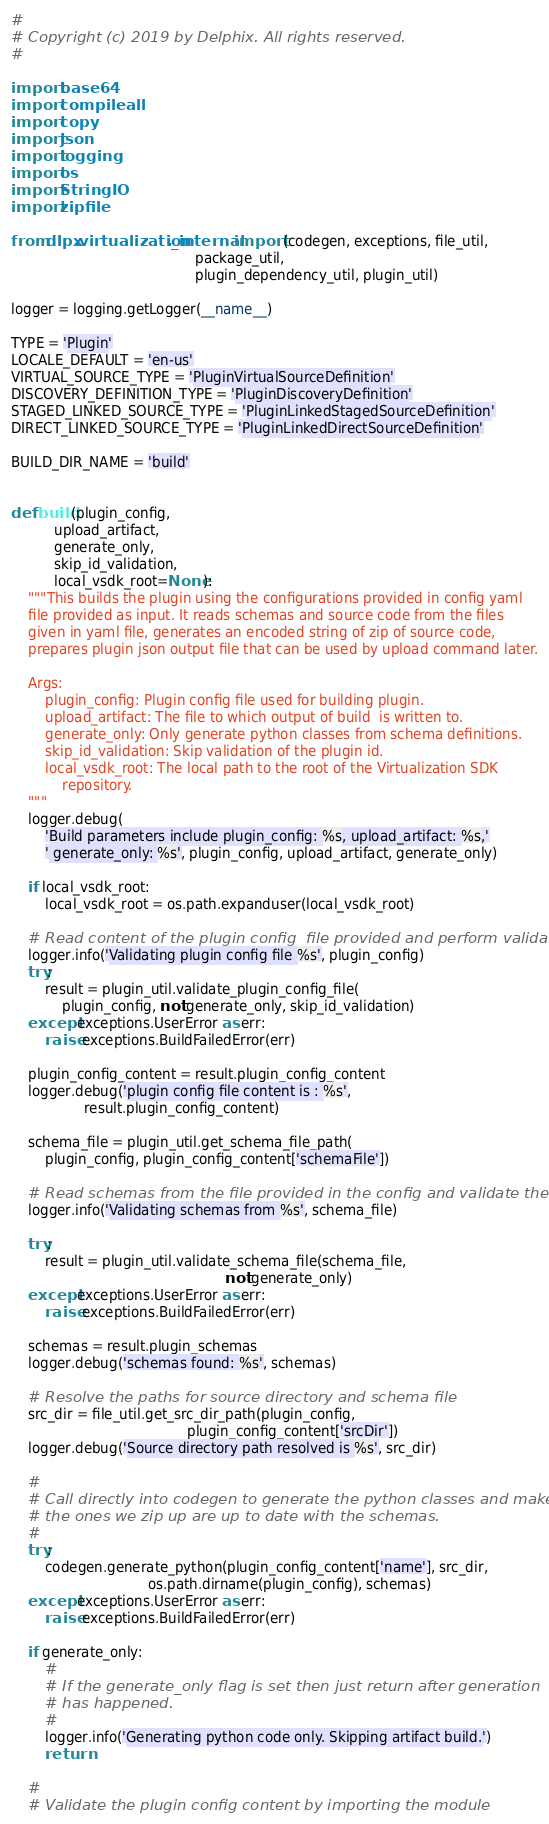<code> <loc_0><loc_0><loc_500><loc_500><_Python_>#
# Copyright (c) 2019 by Delphix. All rights reserved.
#

import base64
import compileall
import copy
import json
import logging
import os
import StringIO
import zipfile

from dlpx.virtualization._internal import (codegen, exceptions, file_util,
                                           package_util,
                                           plugin_dependency_util, plugin_util)

logger = logging.getLogger(__name__)

TYPE = 'Plugin'
LOCALE_DEFAULT = 'en-us'
VIRTUAL_SOURCE_TYPE = 'PluginVirtualSourceDefinition'
DISCOVERY_DEFINITION_TYPE = 'PluginDiscoveryDefinition'
STAGED_LINKED_SOURCE_TYPE = 'PluginLinkedStagedSourceDefinition'
DIRECT_LINKED_SOURCE_TYPE = 'PluginLinkedDirectSourceDefinition'

BUILD_DIR_NAME = 'build'


def build(plugin_config,
          upload_artifact,
          generate_only,
          skip_id_validation,
          local_vsdk_root=None):
    """This builds the plugin using the configurations provided in config yaml
    file provided as input. It reads schemas and source code from the files
    given in yaml file, generates an encoded string of zip of source code,
    prepares plugin json output file that can be used by upload command later.

    Args:
        plugin_config: Plugin config file used for building plugin.
        upload_artifact: The file to which output of build  is written to.
        generate_only: Only generate python classes from schema definitions.
        skip_id_validation: Skip validation of the plugin id.
        local_vsdk_root: The local path to the root of the Virtualization SDK
            repository.
    """
    logger.debug(
        'Build parameters include plugin_config: %s, upload_artifact: %s,'
        ' generate_only: %s', plugin_config, upload_artifact, generate_only)

    if local_vsdk_root:
        local_vsdk_root = os.path.expanduser(local_vsdk_root)

    # Read content of the plugin config  file provided and perform validations
    logger.info('Validating plugin config file %s', plugin_config)
    try:
        result = plugin_util.validate_plugin_config_file(
            plugin_config, not generate_only, skip_id_validation)
    except exceptions.UserError as err:
        raise exceptions.BuildFailedError(err)

    plugin_config_content = result.plugin_config_content
    logger.debug('plugin config file content is : %s',
                 result.plugin_config_content)

    schema_file = plugin_util.get_schema_file_path(
        plugin_config, plugin_config_content['schemaFile'])

    # Read schemas from the file provided in the config and validate them
    logger.info('Validating schemas from %s', schema_file)

    try:
        result = plugin_util.validate_schema_file(schema_file,
                                                  not generate_only)
    except exceptions.UserError as err:
        raise exceptions.BuildFailedError(err)

    schemas = result.plugin_schemas
    logger.debug('schemas found: %s', schemas)

    # Resolve the paths for source directory and schema file
    src_dir = file_util.get_src_dir_path(plugin_config,
                                         plugin_config_content['srcDir'])
    logger.debug('Source directory path resolved is %s', src_dir)

    #
    # Call directly into codegen to generate the python classes and make sure
    # the ones we zip up are up to date with the schemas.
    #
    try:
        codegen.generate_python(plugin_config_content['name'], src_dir,
                                os.path.dirname(plugin_config), schemas)
    except exceptions.UserError as err:
        raise exceptions.BuildFailedError(err)

    if generate_only:
        #
        # If the generate_only flag is set then just return after generation
        # has happened.
        #
        logger.info('Generating python code only. Skipping artifact build.')
        return

    #
    # Validate the plugin config content by importing the module</code> 